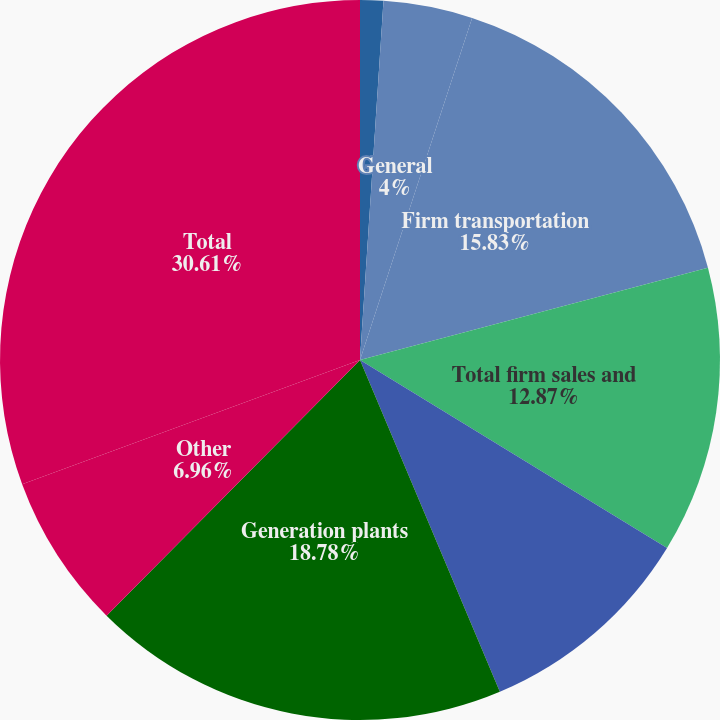Convert chart. <chart><loc_0><loc_0><loc_500><loc_500><pie_chart><fcel>Residential<fcel>General<fcel>Firm transportation<fcel>Total firm sales and<fcel>Interruptible sales<fcel>Generation plants<fcel>Other<fcel>Total<nl><fcel>1.04%<fcel>4.0%<fcel>15.83%<fcel>12.87%<fcel>9.91%<fcel>18.78%<fcel>6.96%<fcel>30.61%<nl></chart> 